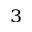<formula> <loc_0><loc_0><loc_500><loc_500>^ { 3 }</formula> 